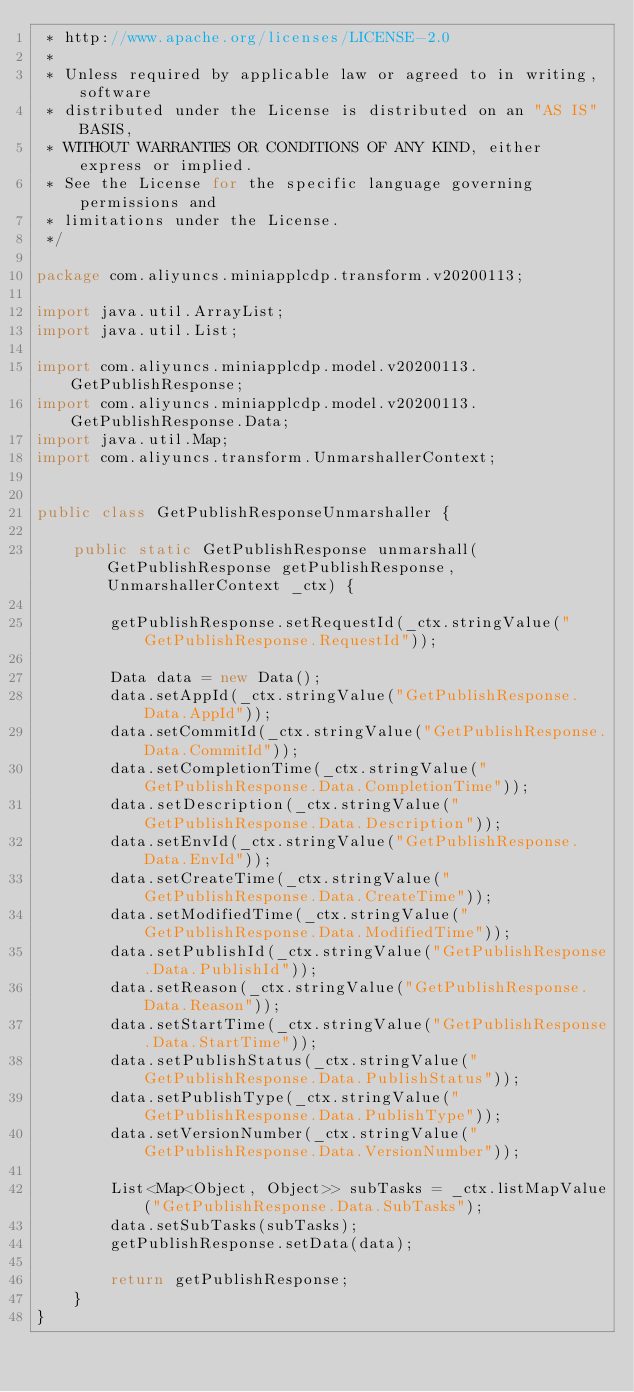<code> <loc_0><loc_0><loc_500><loc_500><_Java_> * http://www.apache.org/licenses/LICENSE-2.0
 *
 * Unless required by applicable law or agreed to in writing, software
 * distributed under the License is distributed on an "AS IS" BASIS,
 * WITHOUT WARRANTIES OR CONDITIONS OF ANY KIND, either express or implied.
 * See the License for the specific language governing permissions and
 * limitations under the License.
 */

package com.aliyuncs.miniapplcdp.transform.v20200113;

import java.util.ArrayList;
import java.util.List;

import com.aliyuncs.miniapplcdp.model.v20200113.GetPublishResponse;
import com.aliyuncs.miniapplcdp.model.v20200113.GetPublishResponse.Data;
import java.util.Map;
import com.aliyuncs.transform.UnmarshallerContext;


public class GetPublishResponseUnmarshaller {

	public static GetPublishResponse unmarshall(GetPublishResponse getPublishResponse, UnmarshallerContext _ctx) {
		
		getPublishResponse.setRequestId(_ctx.stringValue("GetPublishResponse.RequestId"));

		Data data = new Data();
		data.setAppId(_ctx.stringValue("GetPublishResponse.Data.AppId"));
		data.setCommitId(_ctx.stringValue("GetPublishResponse.Data.CommitId"));
		data.setCompletionTime(_ctx.stringValue("GetPublishResponse.Data.CompletionTime"));
		data.setDescription(_ctx.stringValue("GetPublishResponse.Data.Description"));
		data.setEnvId(_ctx.stringValue("GetPublishResponse.Data.EnvId"));
		data.setCreateTime(_ctx.stringValue("GetPublishResponse.Data.CreateTime"));
		data.setModifiedTime(_ctx.stringValue("GetPublishResponse.Data.ModifiedTime"));
		data.setPublishId(_ctx.stringValue("GetPublishResponse.Data.PublishId"));
		data.setReason(_ctx.stringValue("GetPublishResponse.Data.Reason"));
		data.setStartTime(_ctx.stringValue("GetPublishResponse.Data.StartTime"));
		data.setPublishStatus(_ctx.stringValue("GetPublishResponse.Data.PublishStatus"));
		data.setPublishType(_ctx.stringValue("GetPublishResponse.Data.PublishType"));
		data.setVersionNumber(_ctx.stringValue("GetPublishResponse.Data.VersionNumber"));

		List<Map<Object, Object>> subTasks = _ctx.listMapValue("GetPublishResponse.Data.SubTasks");
		data.setSubTasks(subTasks);
		getPublishResponse.setData(data);
	 
	 	return getPublishResponse;
	}
}</code> 